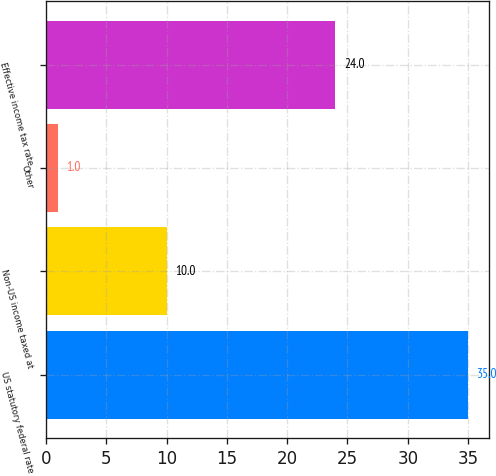Convert chart to OTSL. <chart><loc_0><loc_0><loc_500><loc_500><bar_chart><fcel>US statutory federal rate<fcel>Non-US income taxed at<fcel>Other<fcel>Effective income tax rate<nl><fcel>35<fcel>10<fcel>1<fcel>24<nl></chart> 